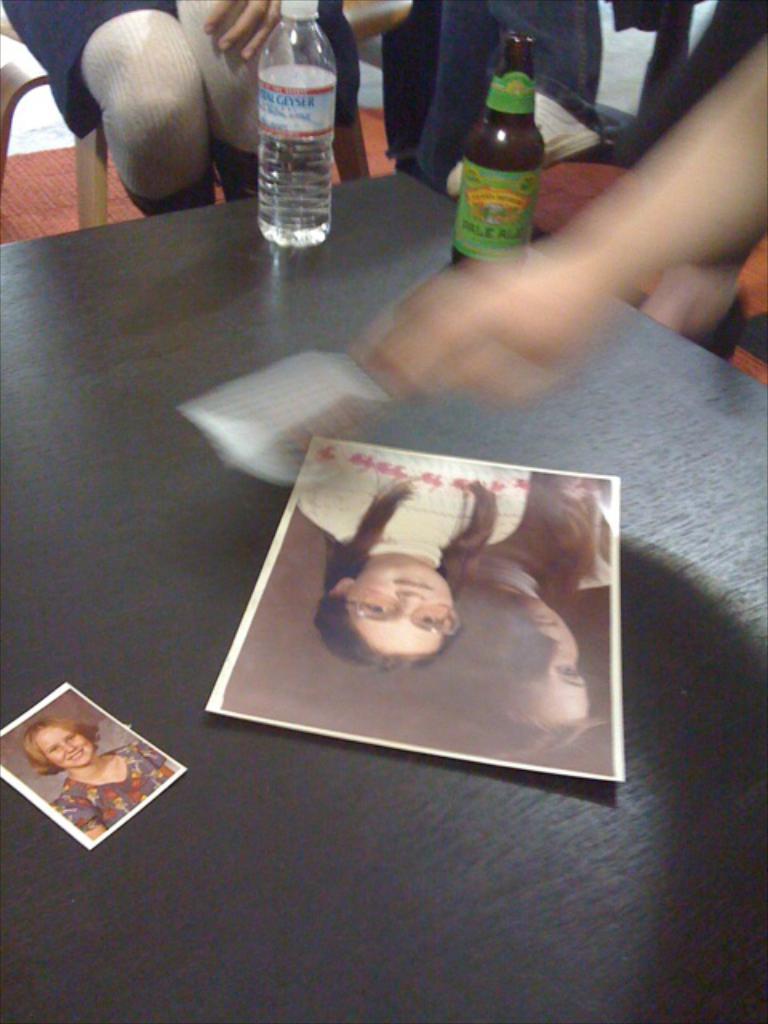Describe this image in one or two sentences. In this picture we can see table and on table we have photos, bottle and aside to this table persons sitting on chair. 